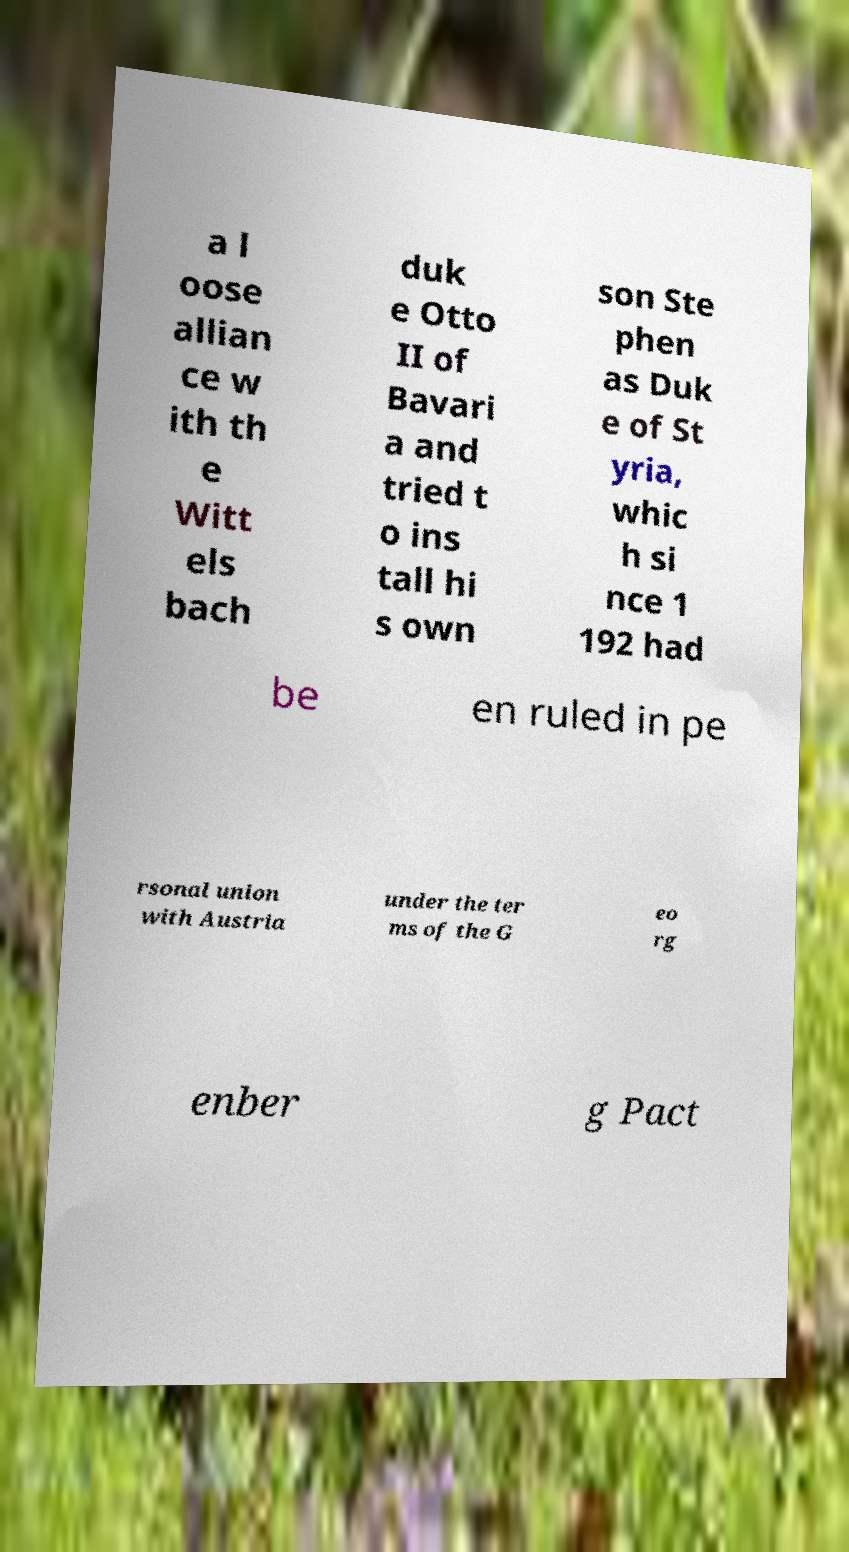Please read and relay the text visible in this image. What does it say? a l oose allian ce w ith th e Witt els bach duk e Otto II of Bavari a and tried t o ins tall hi s own son Ste phen as Duk e of St yria, whic h si nce 1 192 had be en ruled in pe rsonal union with Austria under the ter ms of the G eo rg enber g Pact 